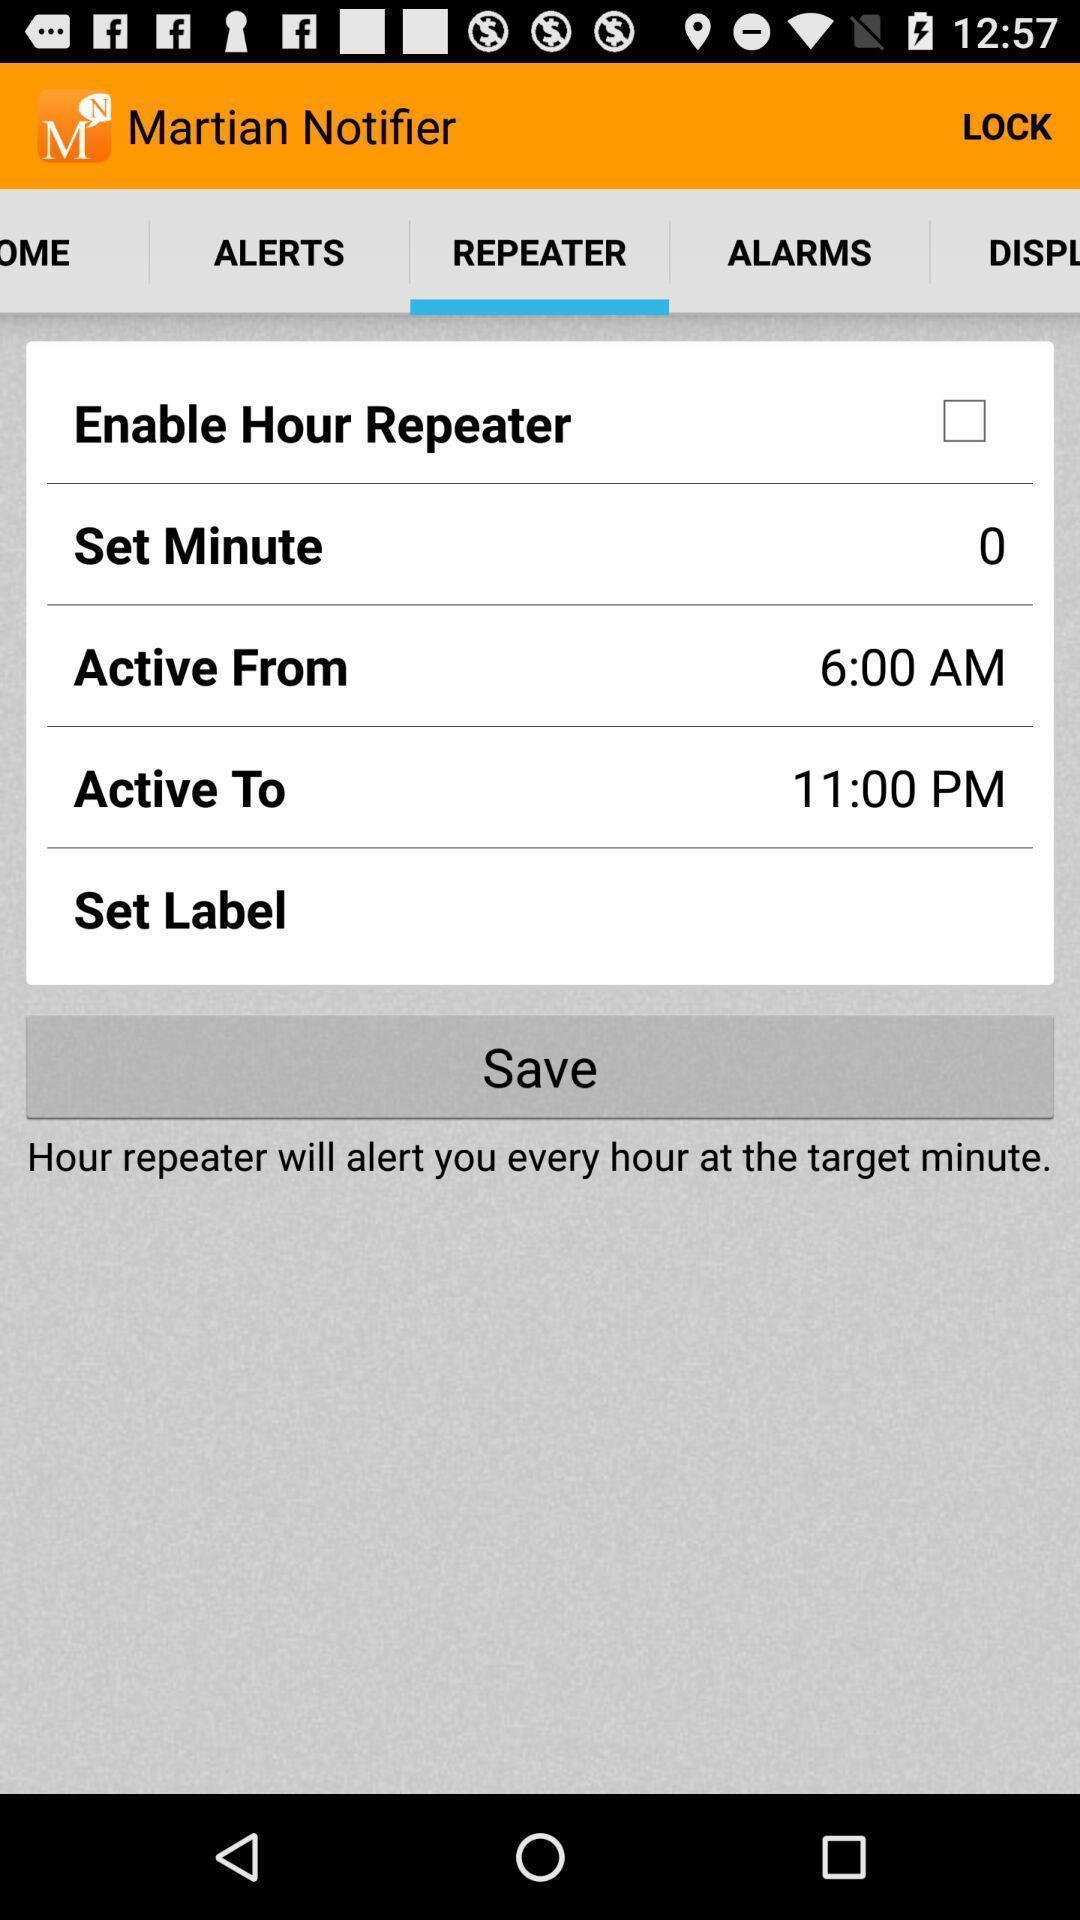Tell me about the visual elements in this screen capture. Screen displaying repeater page in app. 